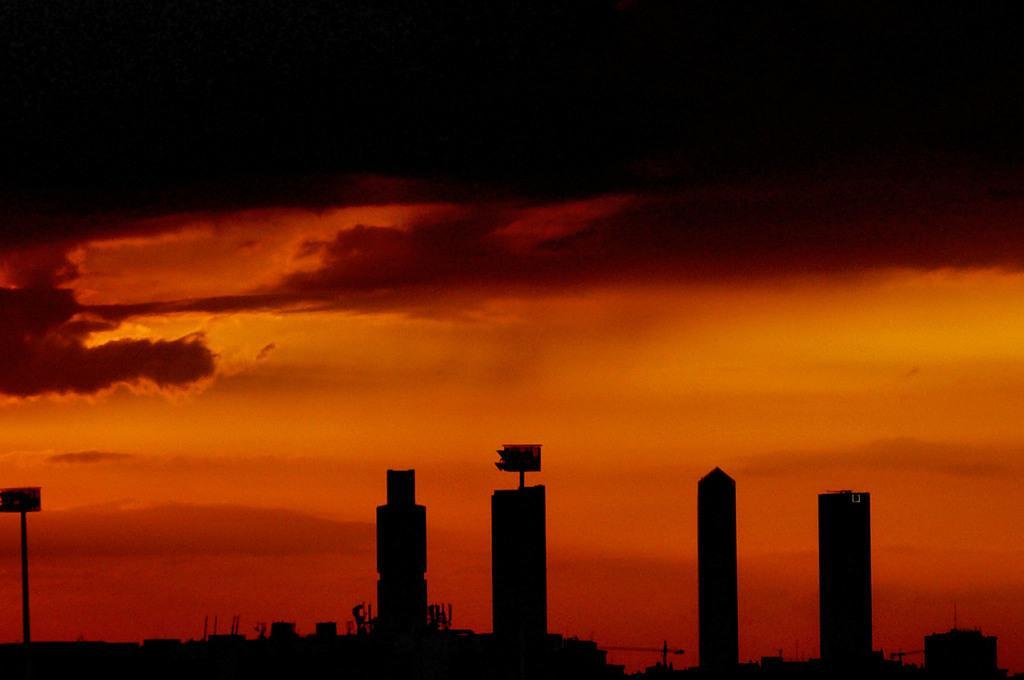How would you summarize this image in a sentence or two? This picture shows few buildings and we see red color sky. 